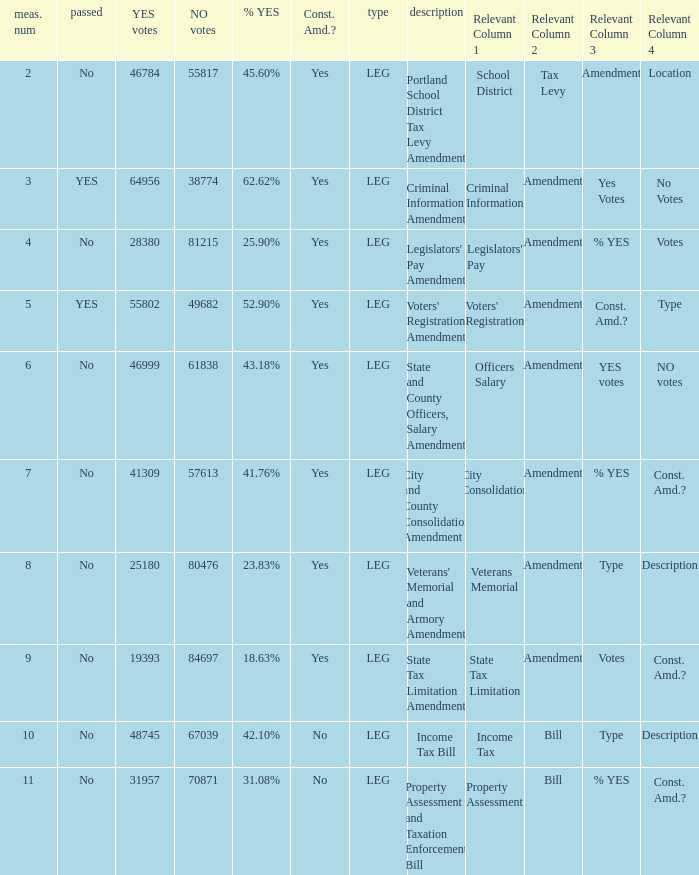HOw many no votes were there when there were 45.60% yes votes 55817.0. 